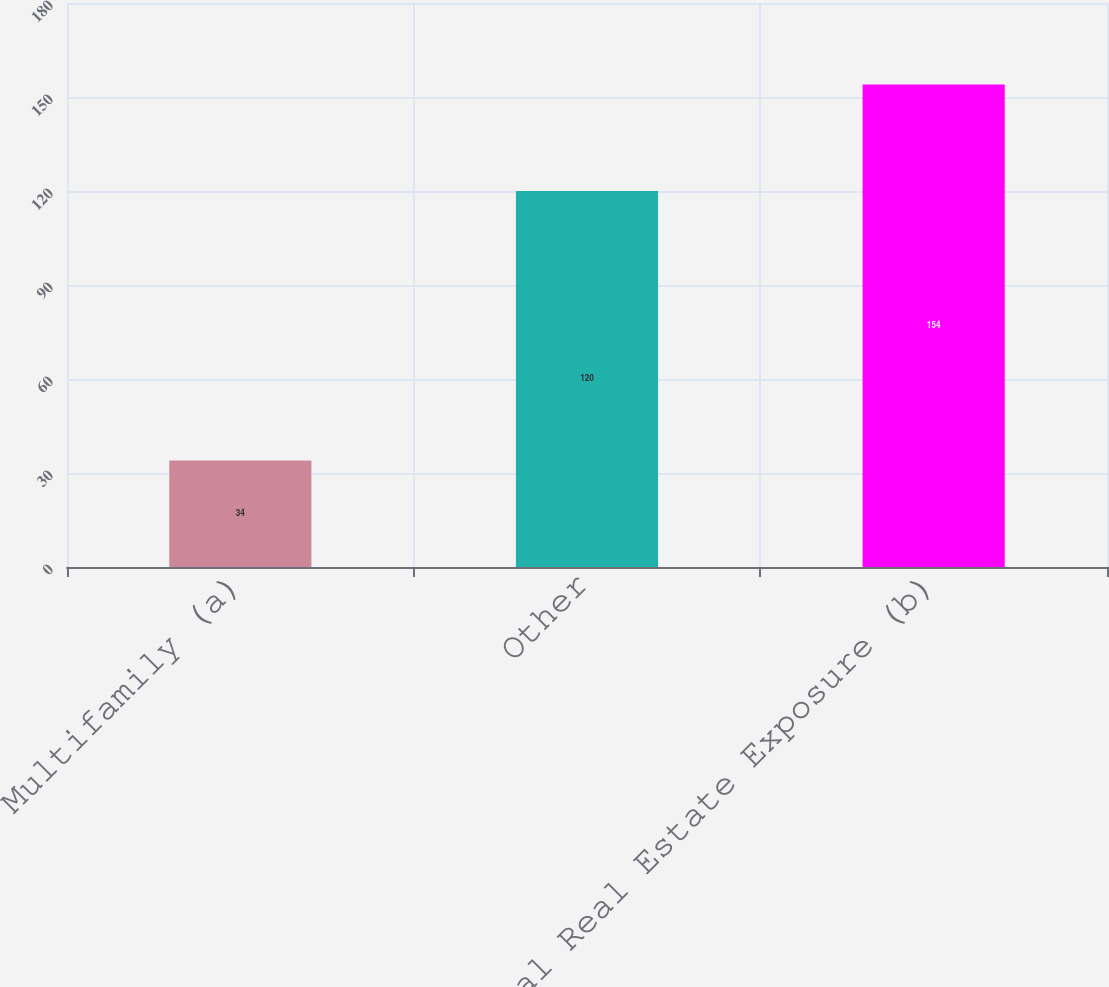<chart> <loc_0><loc_0><loc_500><loc_500><bar_chart><fcel>Multifamily (a)<fcel>Other<fcel>Total Real Estate Exposure (b)<nl><fcel>34<fcel>120<fcel>154<nl></chart> 